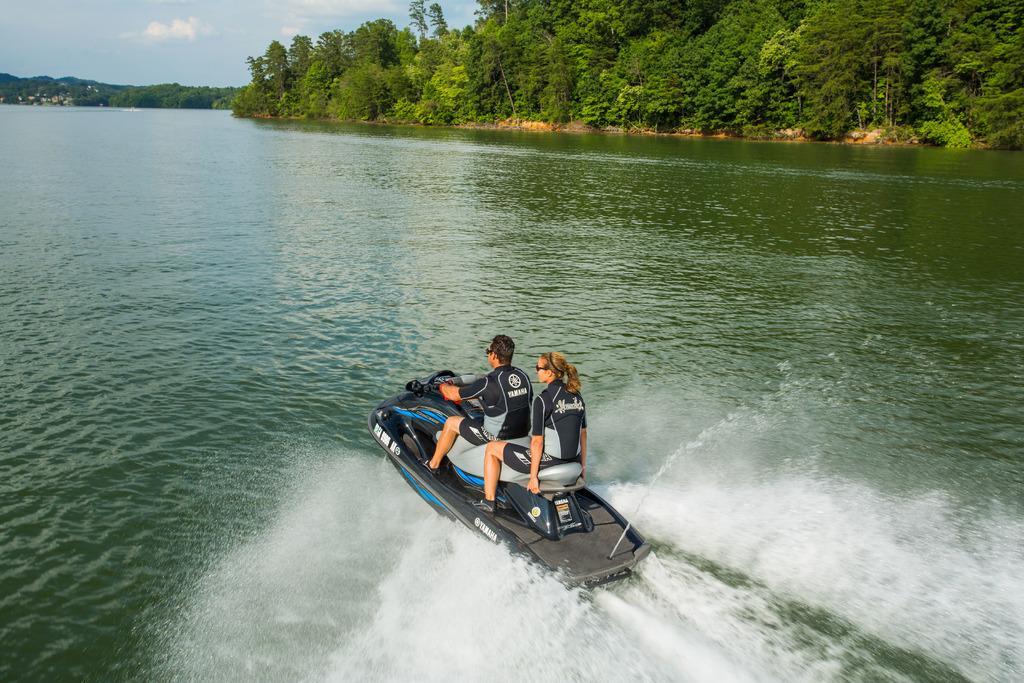Please provide a concise description of this image. In this image we can see a man and woman riding a black color boat on the river water. Behind there are many trees. 